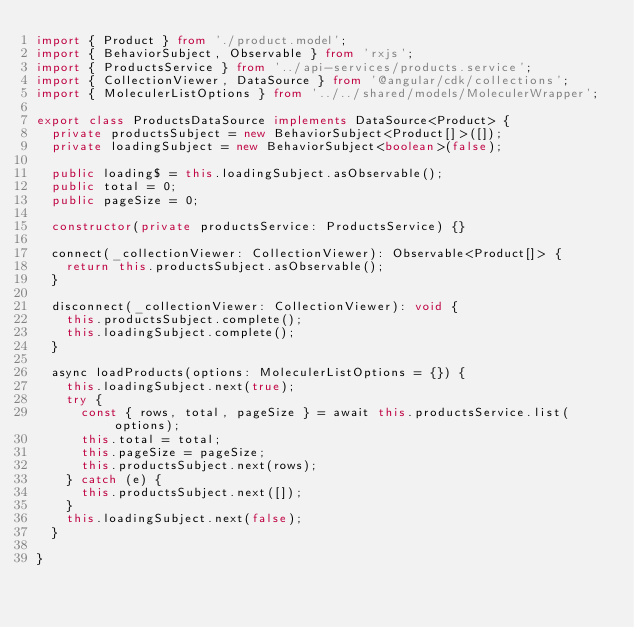Convert code to text. <code><loc_0><loc_0><loc_500><loc_500><_TypeScript_>import { Product } from './product.model';
import { BehaviorSubject, Observable } from 'rxjs';
import { ProductsService } from '../api-services/products.service';
import { CollectionViewer, DataSource } from '@angular/cdk/collections';
import { MoleculerListOptions } from '../../shared/models/MoleculerWrapper';

export class ProductsDataSource implements DataSource<Product> {
  private productsSubject = new BehaviorSubject<Product[]>([]);
  private loadingSubject = new BehaviorSubject<boolean>(false);

  public loading$ = this.loadingSubject.asObservable();
  public total = 0;
  public pageSize = 0;

  constructor(private productsService: ProductsService) {}

  connect(_collectionViewer: CollectionViewer): Observable<Product[]> {
    return this.productsSubject.asObservable();
  }

  disconnect(_collectionViewer: CollectionViewer): void {
    this.productsSubject.complete();
    this.loadingSubject.complete();
  }

  async loadProducts(options: MoleculerListOptions = {}) {
    this.loadingSubject.next(true);
    try {
      const { rows, total, pageSize } = await this.productsService.list(options);
      this.total = total;
      this.pageSize = pageSize;
      this.productsSubject.next(rows);
    } catch (e) {
      this.productsSubject.next([]);
    }
    this.loadingSubject.next(false);
  }

}
</code> 